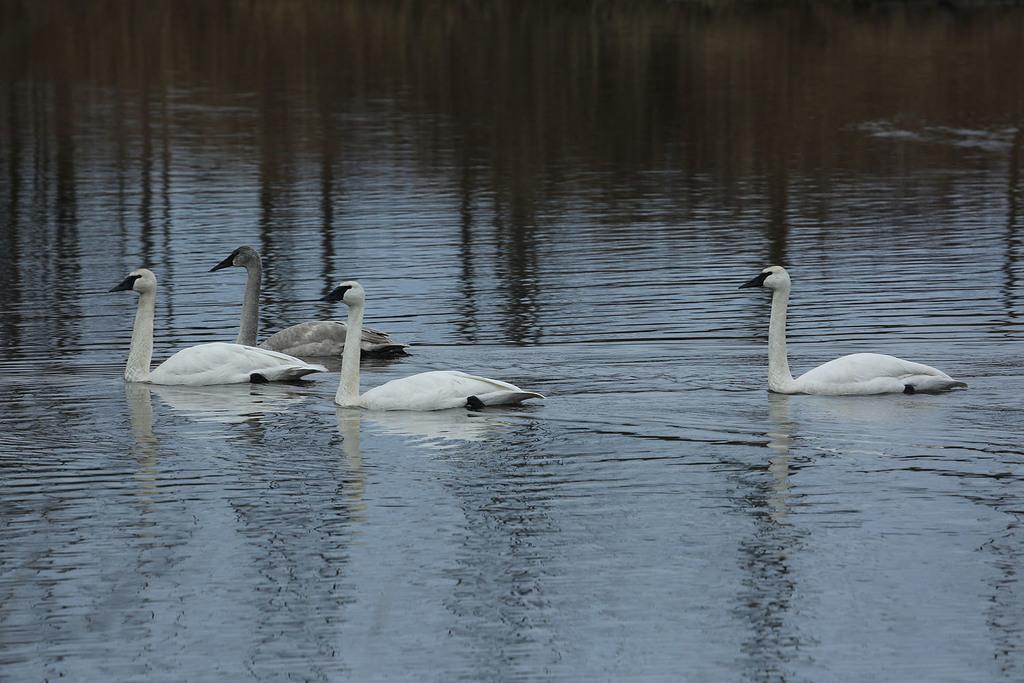What type of animals can be seen in the water in the image? There are swans in the water in the image. What type of lettuce can be seen growing near the swans in the image? There is no lettuce present in the image; it only features swans in the water. 